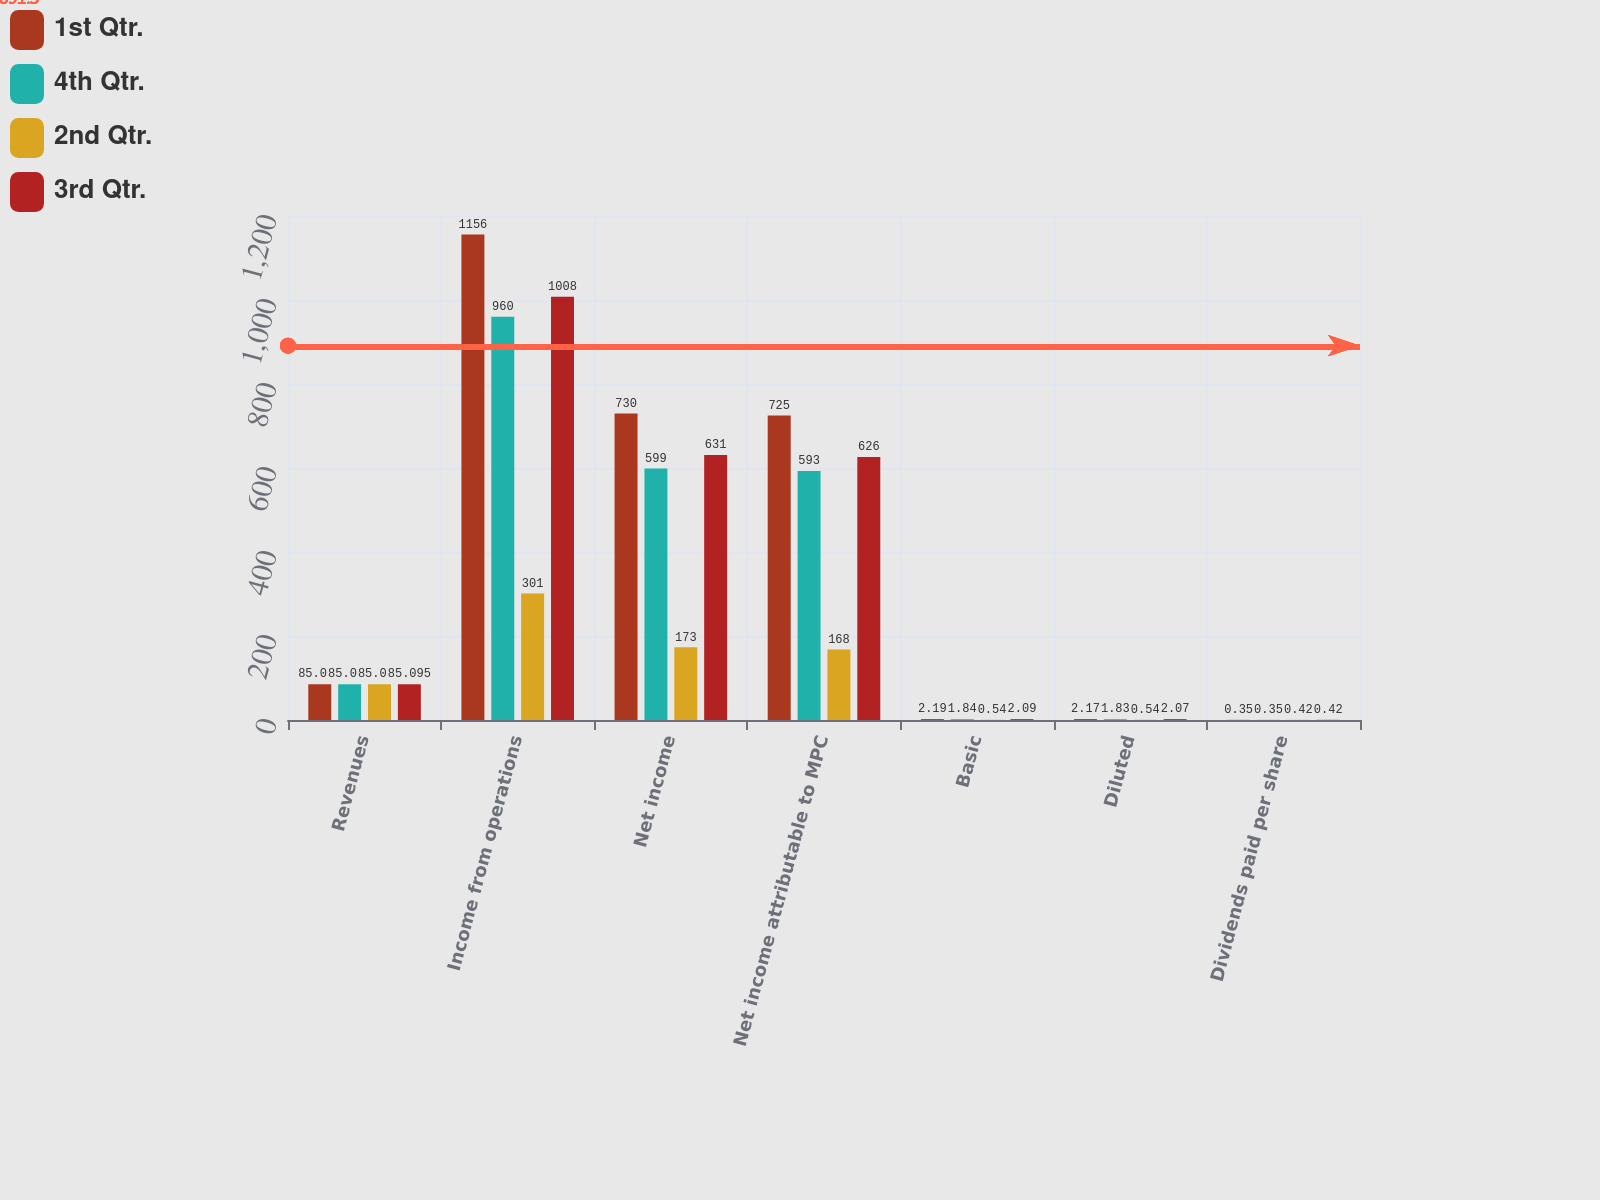<chart> <loc_0><loc_0><loc_500><loc_500><stacked_bar_chart><ecel><fcel>Revenues<fcel>Income from operations<fcel>Net income<fcel>Net income attributable to MPC<fcel>Basic<fcel>Diluted<fcel>Dividends paid per share<nl><fcel>1st Qtr.<fcel>85.095<fcel>1156<fcel>730<fcel>725<fcel>2.19<fcel>2.17<fcel>0.35<nl><fcel>4th Qtr.<fcel>85.095<fcel>960<fcel>599<fcel>593<fcel>1.84<fcel>1.83<fcel>0.35<nl><fcel>2nd Qtr.<fcel>85.095<fcel>301<fcel>173<fcel>168<fcel>0.54<fcel>0.54<fcel>0.42<nl><fcel>3rd Qtr.<fcel>85.095<fcel>1008<fcel>631<fcel>626<fcel>2.09<fcel>2.07<fcel>0.42<nl></chart> 